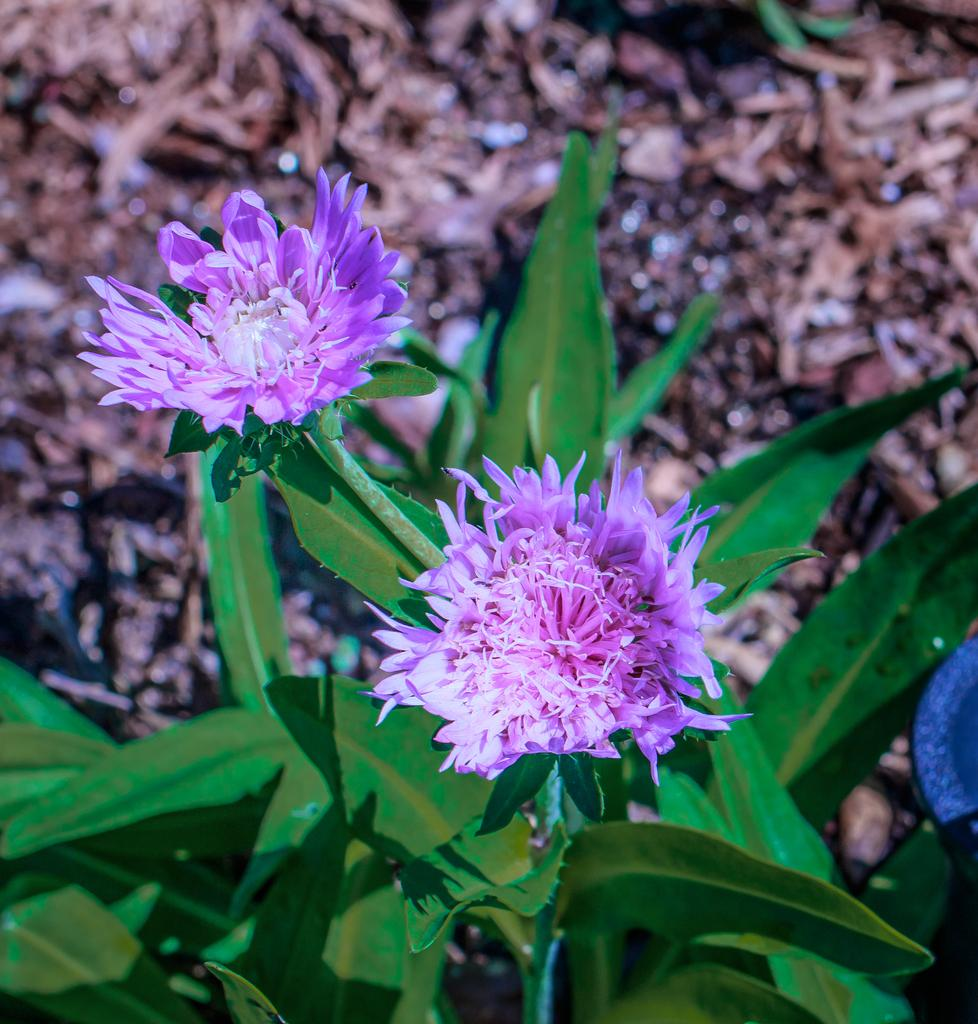What type of plants can be seen in the image? There are flowers and leaves in the image. Can you describe the background of the image? The background of the image is blurry. What type of bomb is visible in the image? There is no bomb present in the image. What level of detail can be seen in the image? The level of detail in the image cannot be determined from the provided facts, as they only mention the presence of flowers, leaves, and a blurry background. 